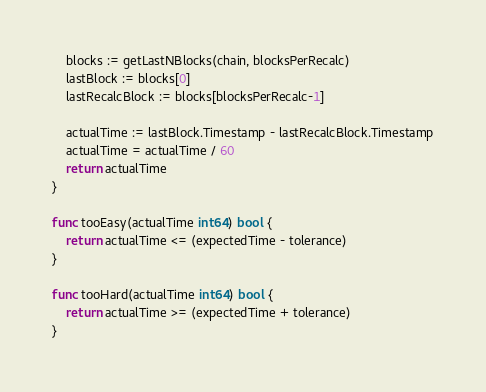<code> <loc_0><loc_0><loc_500><loc_500><_Go_>	blocks := getLastNBlocks(chain, blocksPerRecalc)
	lastBlock := blocks[0]
	lastRecalcBlock := blocks[blocksPerRecalc-1]

	actualTime := lastBlock.Timestamp - lastRecalcBlock.Timestamp
	actualTime = actualTime / 60
	return actualTime
}

func tooEasy(actualTime int64) bool {
	return actualTime <= (expectedTime - tolerance)
}

func tooHard(actualTime int64) bool {
	return actualTime >= (expectedTime + tolerance)
}
</code> 